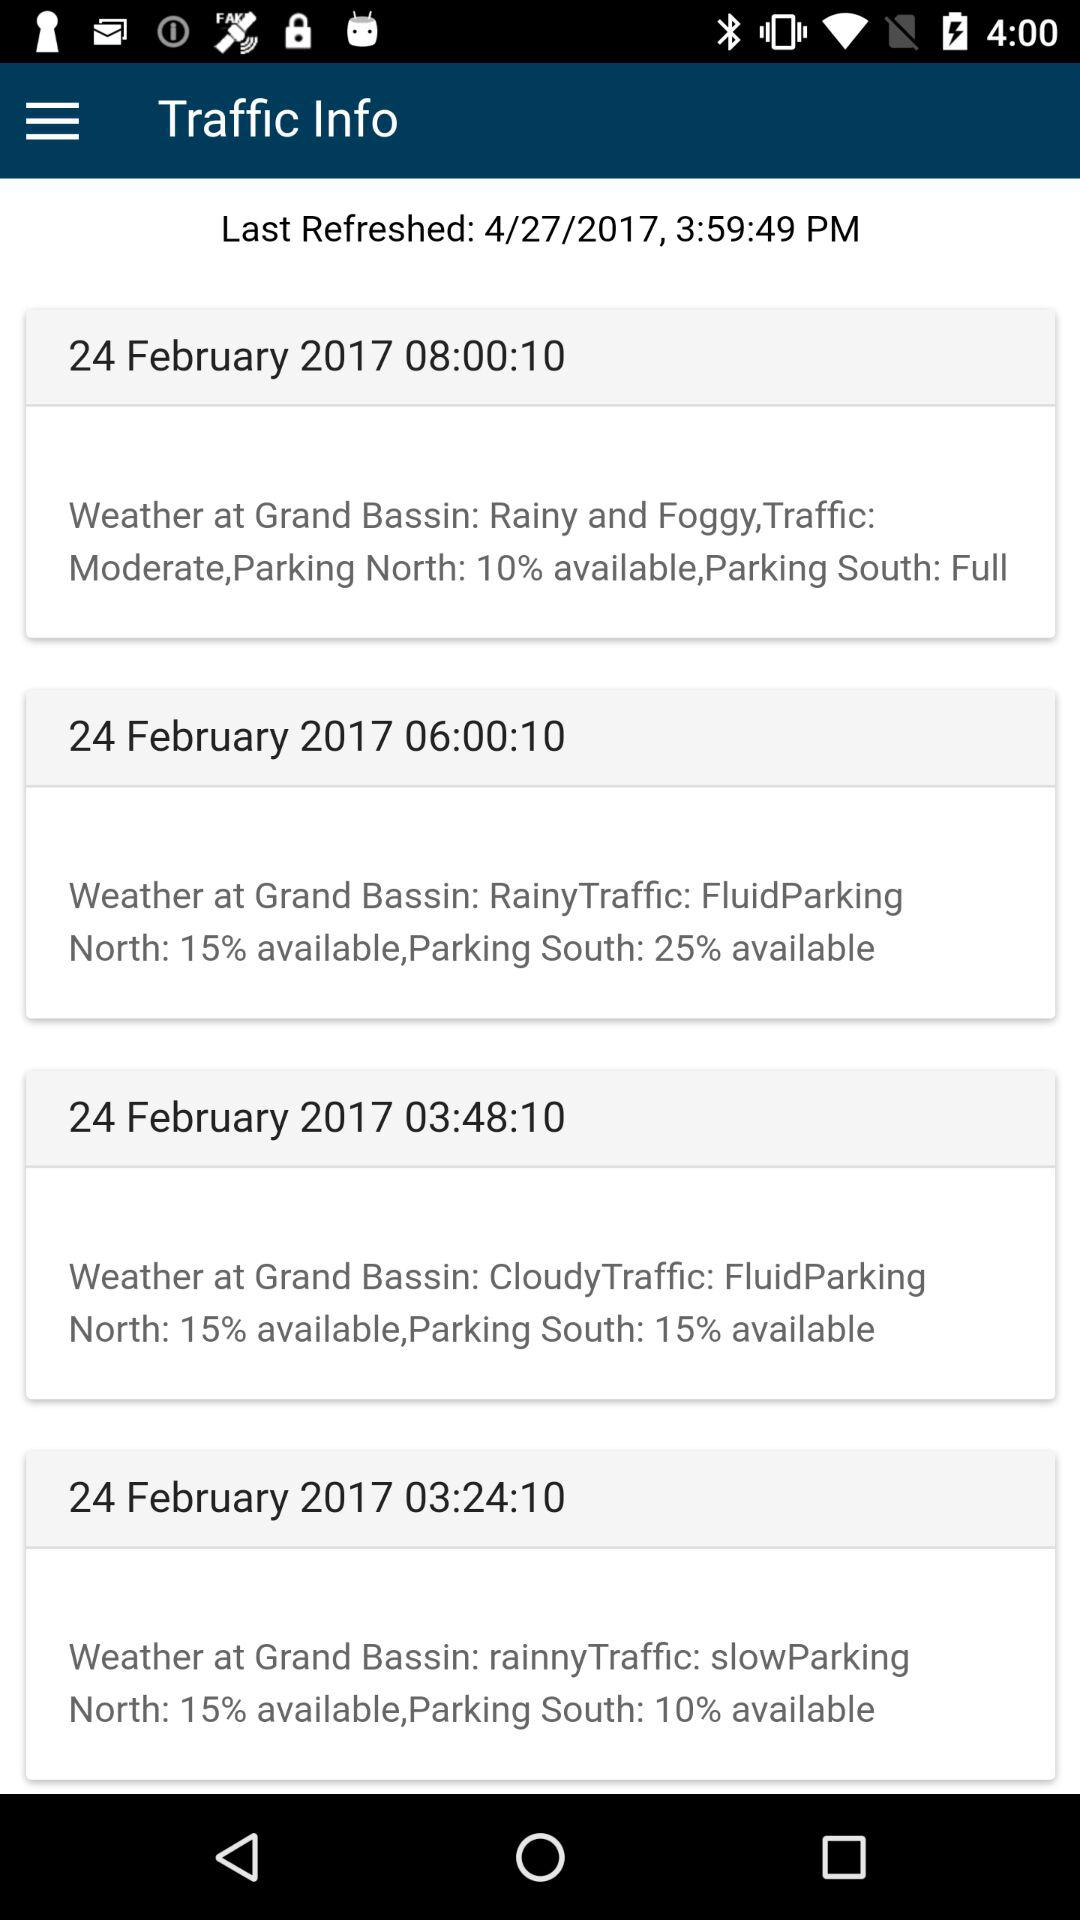What location's weather is mentioned? The Grand Bassin weather is mentioned. 